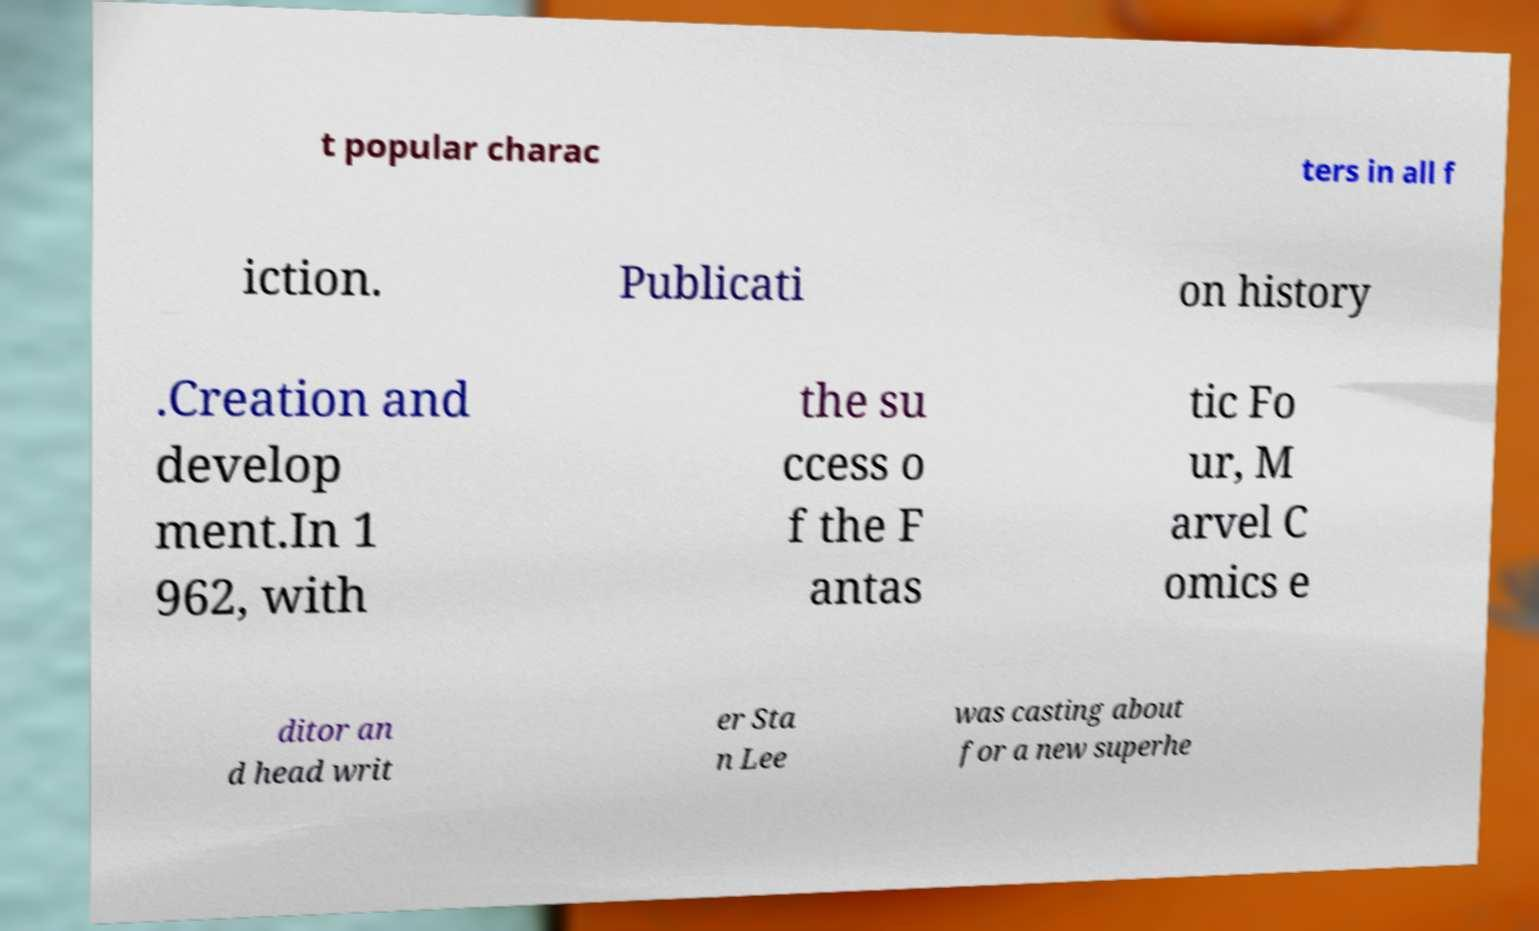There's text embedded in this image that I need extracted. Can you transcribe it verbatim? t popular charac ters in all f iction. Publicati on history .Creation and develop ment.In 1 962, with the su ccess o f the F antas tic Fo ur, M arvel C omics e ditor an d head writ er Sta n Lee was casting about for a new superhe 